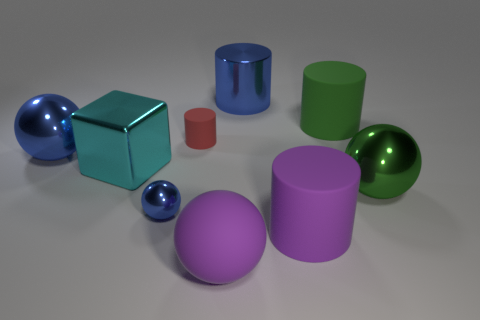Do the large shiny cylinder and the tiny metal ball have the same color?
Ensure brevity in your answer.  Yes. There is a large cylinder that is the same color as the small shiny ball; what is its material?
Your response must be concise. Metal. There is a large blue metal sphere; are there any matte things behind it?
Keep it short and to the point. Yes. Are there more big blue metallic objects than tiny brown metal cubes?
Ensure brevity in your answer.  Yes. What is the color of the shiny sphere left of the blue ball in front of the large blue thing that is left of the rubber sphere?
Your response must be concise. Blue. There is a sphere that is the same material as the purple cylinder; what color is it?
Provide a short and direct response. Purple. How many objects are either blue objects that are on the right side of the red rubber object or metallic objects that are behind the large blue sphere?
Your response must be concise. 1. There is a thing to the right of the green matte cylinder; is it the same size as the purple cylinder right of the cyan metal cube?
Your response must be concise. Yes. There is a big metallic thing that is the same shape as the red rubber object; what is its color?
Provide a short and direct response. Blue. Is there any other thing that is the same shape as the cyan metal thing?
Give a very brief answer. No. 